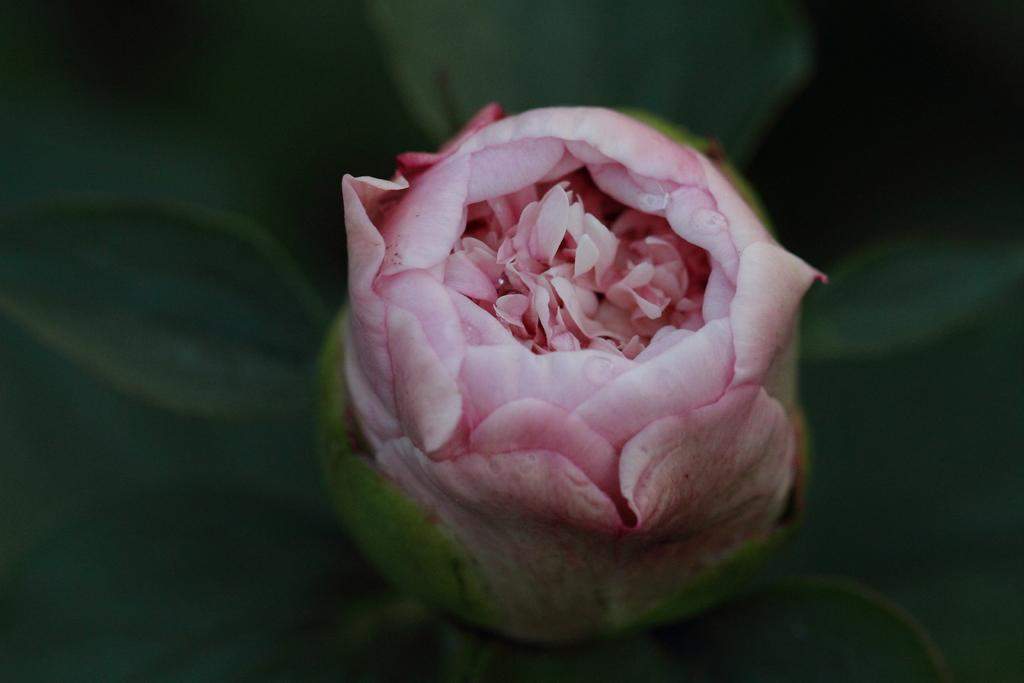What is the main subject in the center of the image? There is a rose in the center of the image. Where is the nest located in the image? There is no nest present in the image; it only features a rose. 